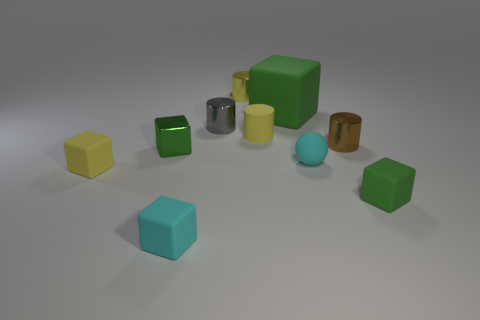Subtract all yellow balls. How many green blocks are left? 3 Subtract all yellow cubes. How many cubes are left? 4 Subtract all brown cubes. Subtract all cyan cylinders. How many cubes are left? 5 Subtract all cylinders. How many objects are left? 6 Subtract 0 purple cubes. How many objects are left? 10 Subtract all tiny green shiny blocks. Subtract all small gray metal cylinders. How many objects are left? 8 Add 8 tiny green rubber blocks. How many tiny green rubber blocks are left? 9 Add 4 tiny green matte cubes. How many tiny green matte cubes exist? 5 